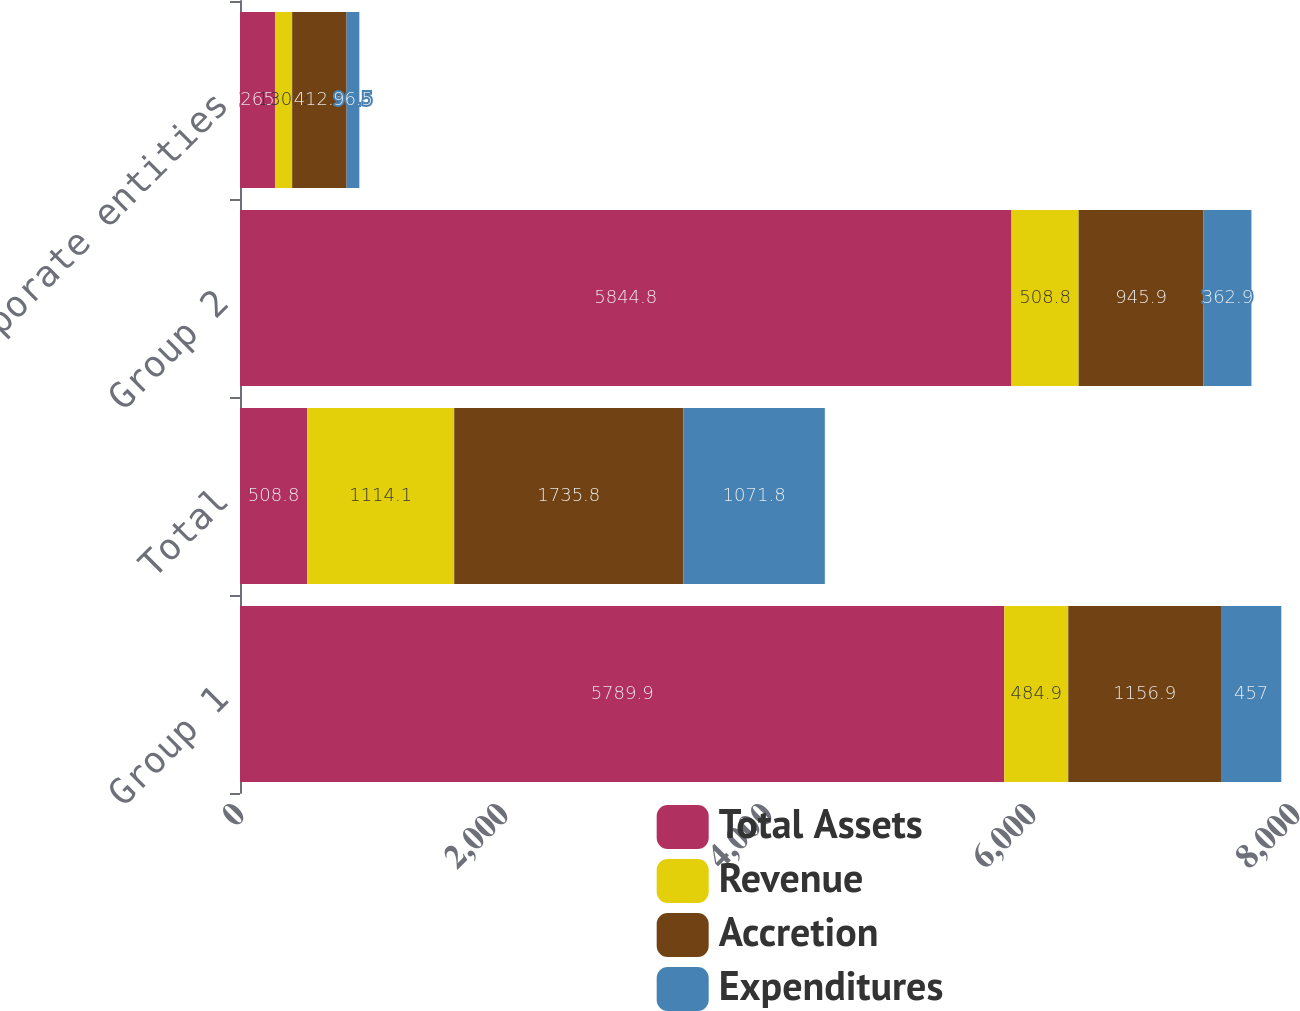<chart> <loc_0><loc_0><loc_500><loc_500><stacked_bar_chart><ecel><fcel>Group 1<fcel>Total<fcel>Group 2<fcel>Corporate entities<nl><fcel>Total Assets<fcel>5789.9<fcel>508.8<fcel>5844.8<fcel>265<nl><fcel>Revenue<fcel>484.9<fcel>1114.1<fcel>508.8<fcel>130.2<nl><fcel>Accretion<fcel>1156.9<fcel>1735.8<fcel>945.9<fcel>412.5<nl><fcel>Expenditures<fcel>457<fcel>1071.8<fcel>362.9<fcel>96.5<nl></chart> 